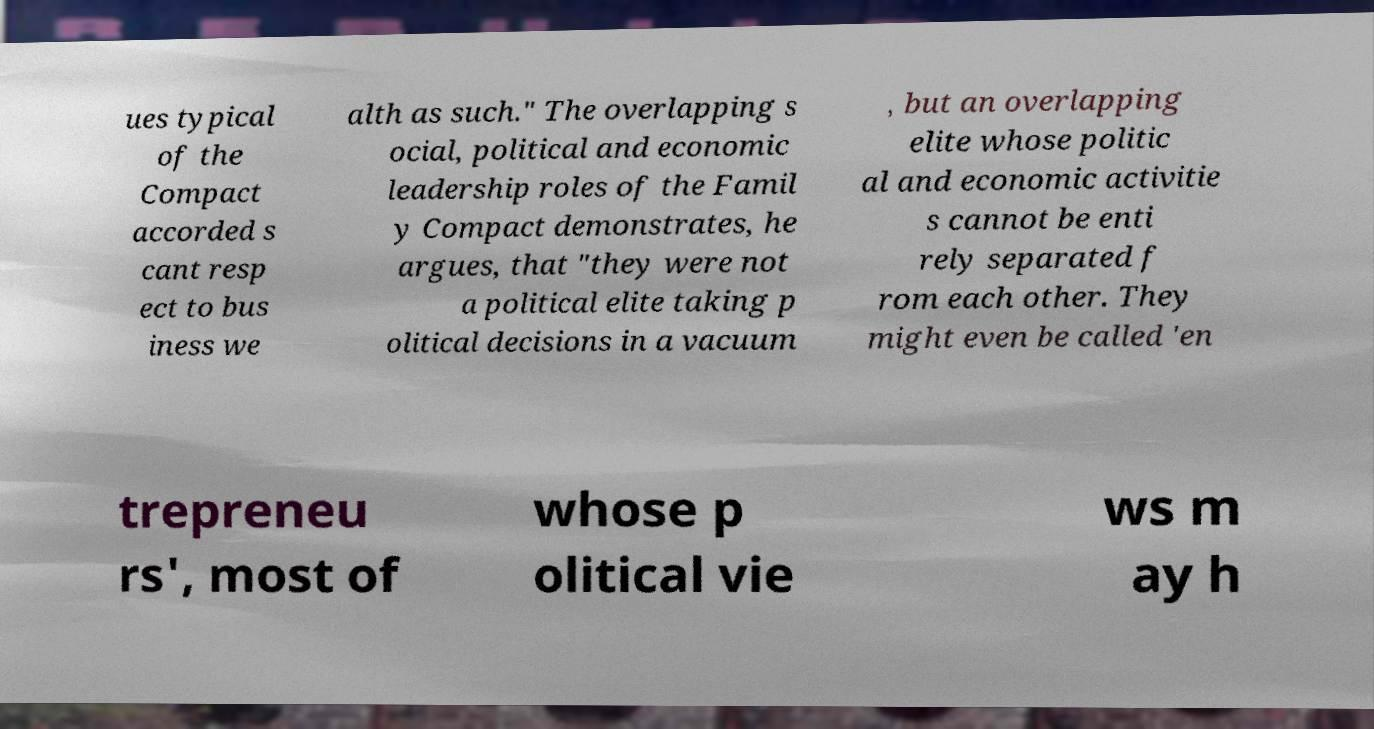I need the written content from this picture converted into text. Can you do that? ues typical of the Compact accorded s cant resp ect to bus iness we alth as such." The overlapping s ocial, political and economic leadership roles of the Famil y Compact demonstrates, he argues, that "they were not a political elite taking p olitical decisions in a vacuum , but an overlapping elite whose politic al and economic activitie s cannot be enti rely separated f rom each other. They might even be called 'en trepreneu rs', most of whose p olitical vie ws m ay h 